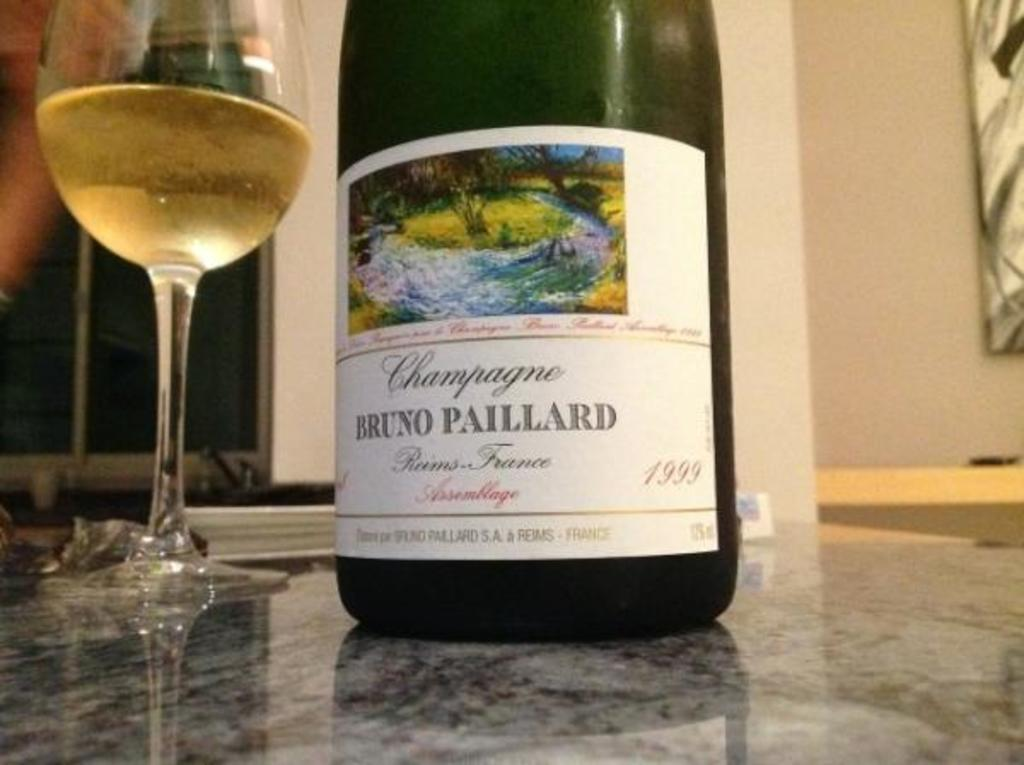What is in the wine glass that is visible in the image? There is a wine glass with wine in the image. What else can be seen in the image besides the wine glass? There is a bottle in the image. Where are the wine glass and bottle located in the image? The wine glass and bottle are placed on the floor in the image. What is attached to the wall in the image? There is a photo frame in the image, and it is attached to the wall. Can you see any birds flying in the image? There are no birds visible in the image. 